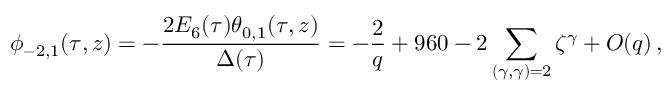<formula> <loc_0><loc_0><loc_500><loc_500>\phi _ { - 2 , 1 } ( \tau , z ) = - \frac { 2 E _ { 6 } ( \tau ) \theta _ { 0 , 1 } ( \tau , z ) } { \Delta ( \tau ) } = - \frac { 2 } { q } + 9 6 0 - 2 \sum _ { ( \gamma , \gamma ) = 2 } \zeta ^ { \gamma } + O ( q ) \, ,</formula> 